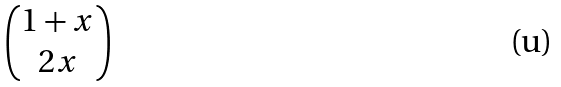<formula> <loc_0><loc_0><loc_500><loc_500>\begin{pmatrix} 1 + x \\ 2 x \end{pmatrix}</formula> 